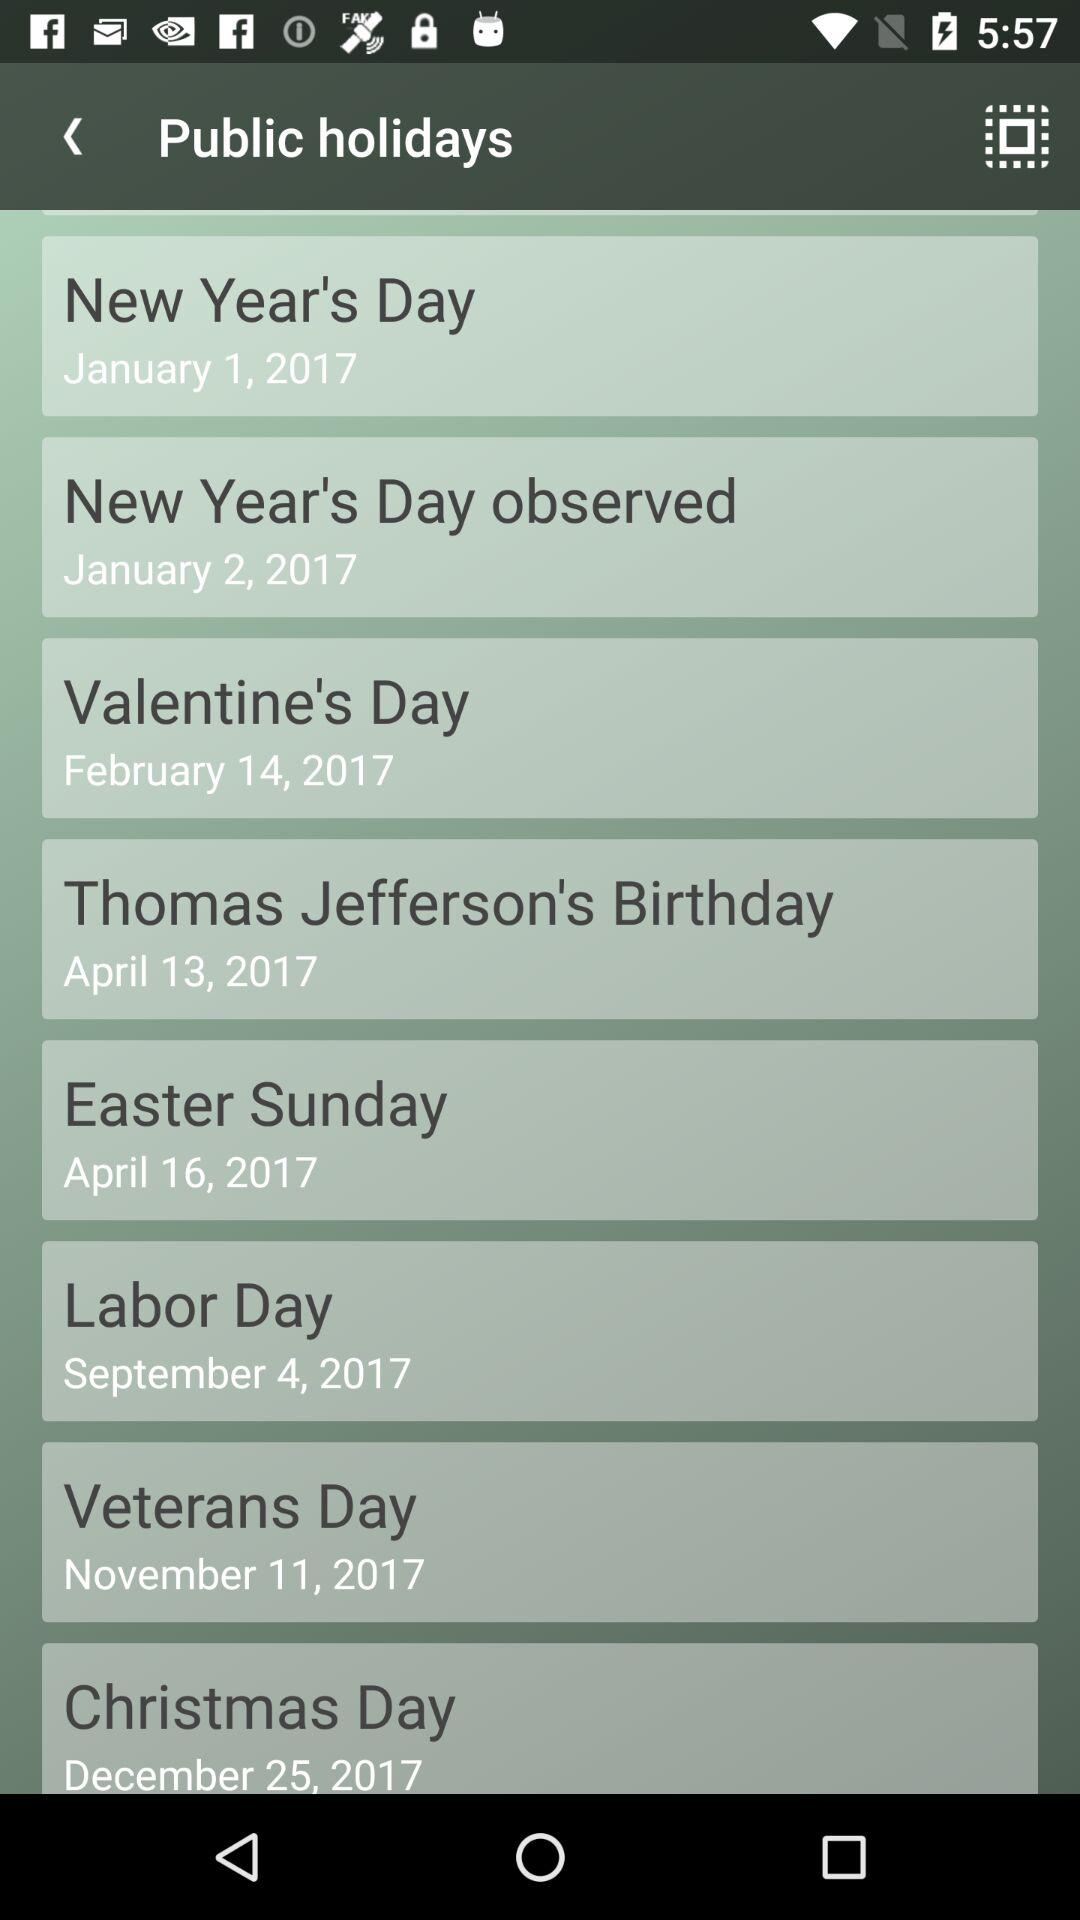When is the "Valentine's Day"? "Valentine's Day" is on February 14, 2017. 